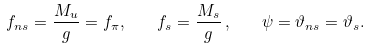<formula> <loc_0><loc_0><loc_500><loc_500>f _ { n s } = \frac { M _ { u } } { g } = f _ { \pi } , \quad f _ { s } = \frac { M _ { s } } { g } \, , \quad \psi = \vartheta _ { n s } = \vartheta _ { s } .</formula> 